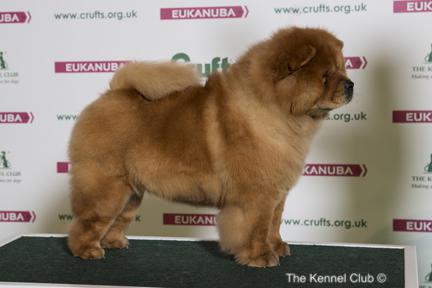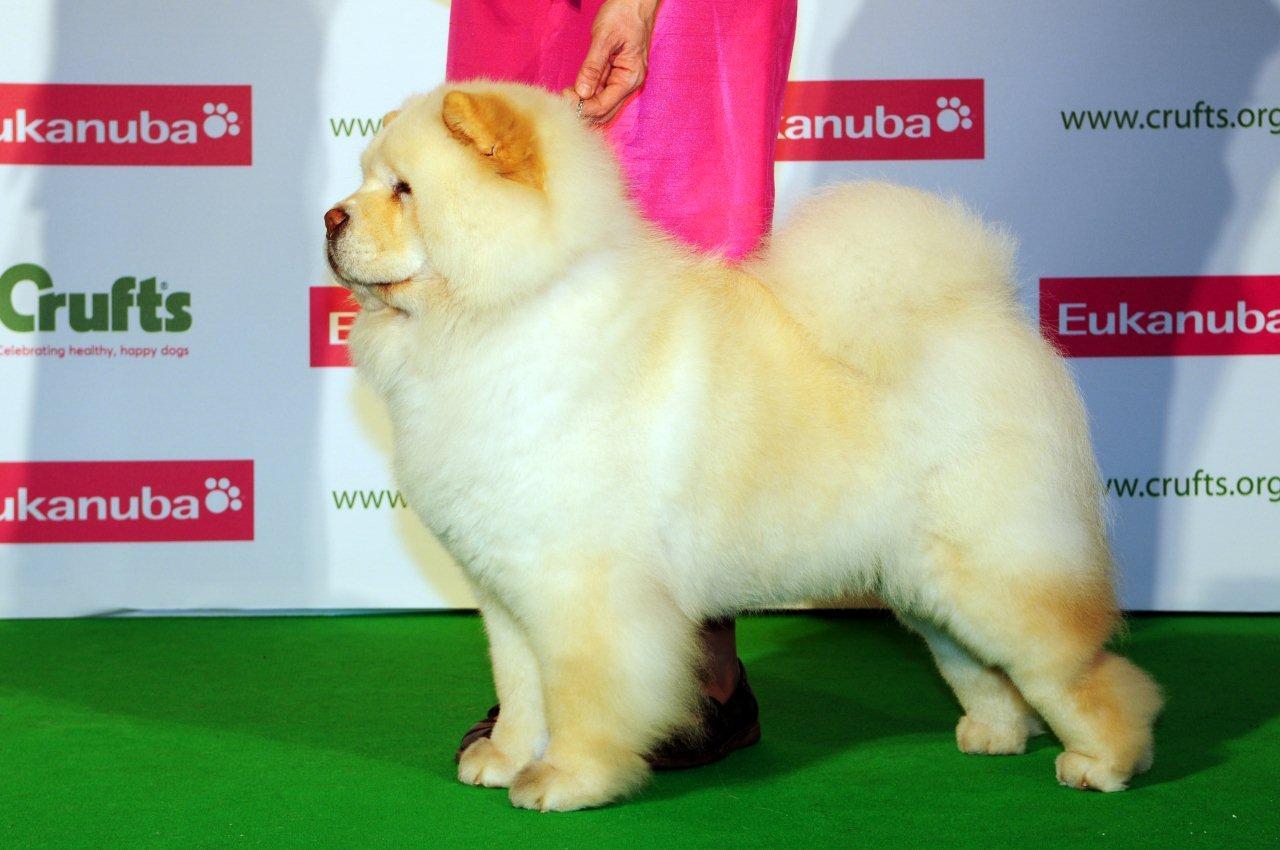The first image is the image on the left, the second image is the image on the right. For the images shown, is this caption "The dogs on the left are facing right." true? Answer yes or no. Yes. 